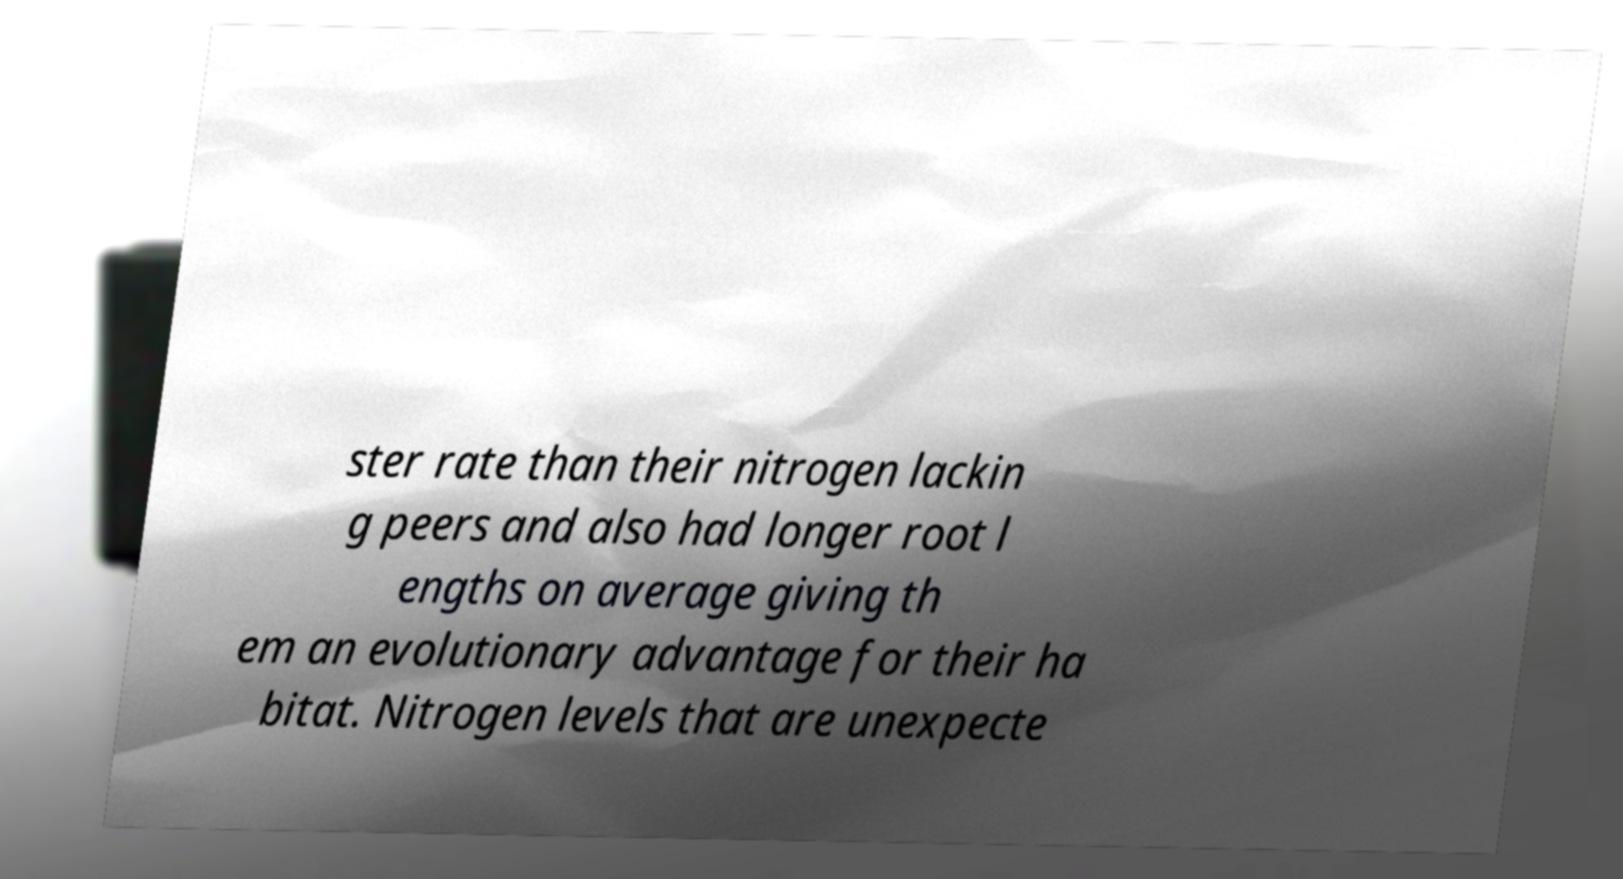There's text embedded in this image that I need extracted. Can you transcribe it verbatim? ster rate than their nitrogen lackin g peers and also had longer root l engths on average giving th em an evolutionary advantage for their ha bitat. Nitrogen levels that are unexpecte 